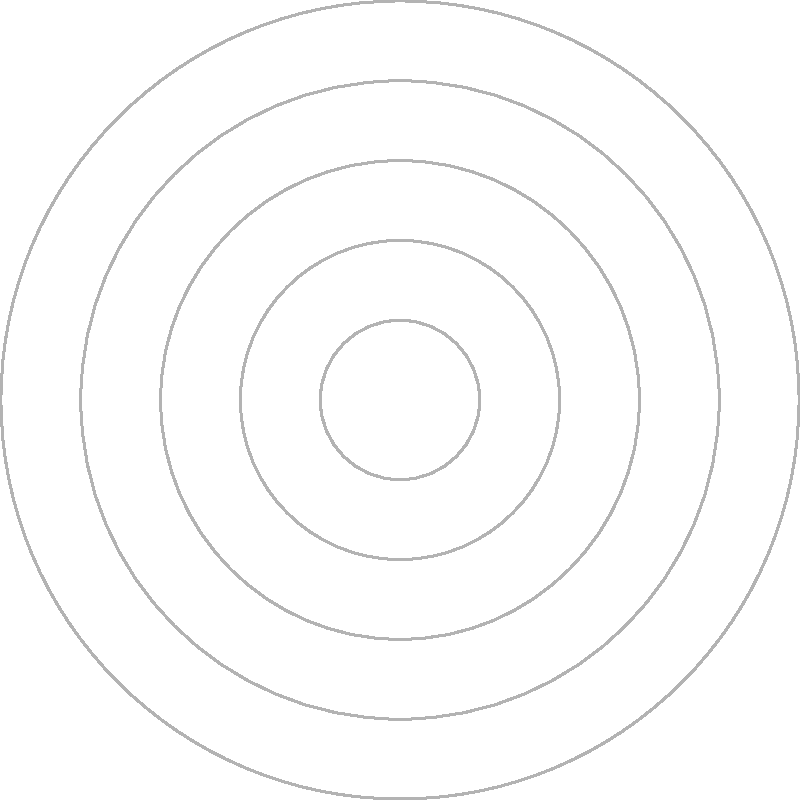As the campus blogger, you're creating a visually appealing map of key campus buildings. Using the polar coordinate system shown, which building is located at coordinates $(r, \theta) = (3, 120^\circ)$? To answer this question, we need to understand how to read polar coordinates and match them to the given plot. Let's break it down step-by-step:

1. Polar coordinates are given in the form $(r, \theta)$, where:
   - $r$ is the distance from the origin (center)
   - $\theta$ is the angle from the positive x-axis (0° line)

2. We're looking for the point $(3, 120^\circ)$:
   - The radial distance $r = 3$ (3 units from the center)
   - The angle $\theta = 120^\circ$ (measured counterclockwise from the 0° line)

3. Looking at the plot:
   - We can see concentric circles representing different radial distances
   - The angle is measured counterclockwise from the right horizontal line (0°)

4. Tracing from the center:
   - Move 3 units outward (this puts us on the third circle from the center)
   - Rotate 120° counterclockwise from the 0° line

5. At this location, we find a red dot labeled with the letter "B"

Therefore, the building located at coordinates $(3, 120^\circ)$ is Building B.
Answer: B 